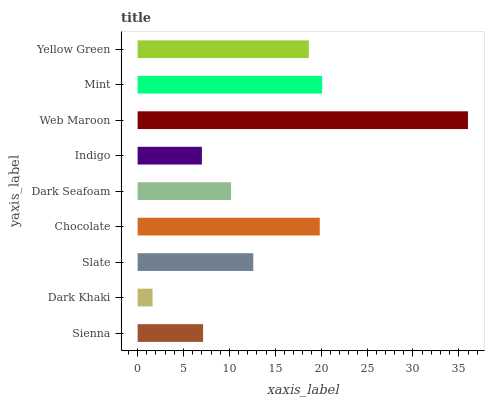Is Dark Khaki the minimum?
Answer yes or no. Yes. Is Web Maroon the maximum?
Answer yes or no. Yes. Is Slate the minimum?
Answer yes or no. No. Is Slate the maximum?
Answer yes or no. No. Is Slate greater than Dark Khaki?
Answer yes or no. Yes. Is Dark Khaki less than Slate?
Answer yes or no. Yes. Is Dark Khaki greater than Slate?
Answer yes or no. No. Is Slate less than Dark Khaki?
Answer yes or no. No. Is Slate the high median?
Answer yes or no. Yes. Is Slate the low median?
Answer yes or no. Yes. Is Yellow Green the high median?
Answer yes or no. No. Is Dark Khaki the low median?
Answer yes or no. No. 